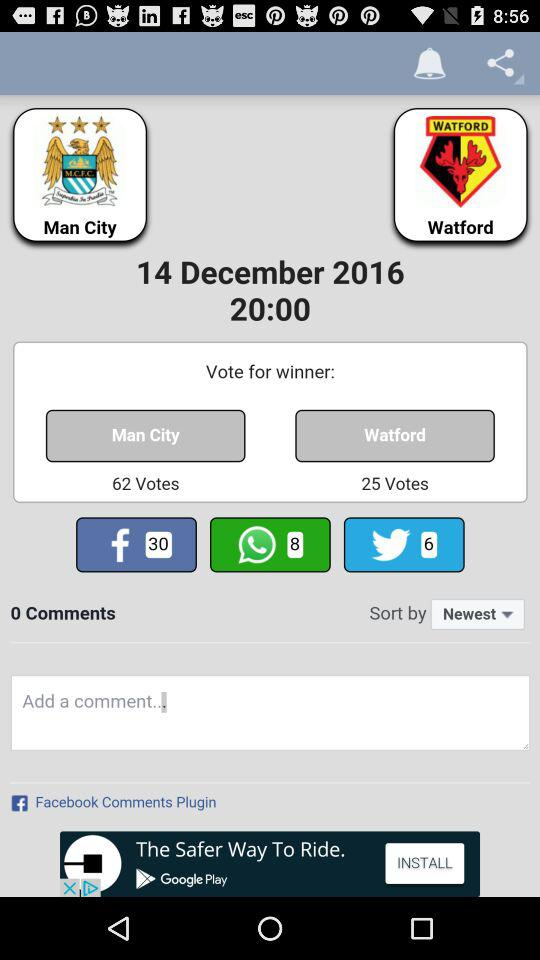What is the team's name? The team's names are "Man City" and "Watford". 